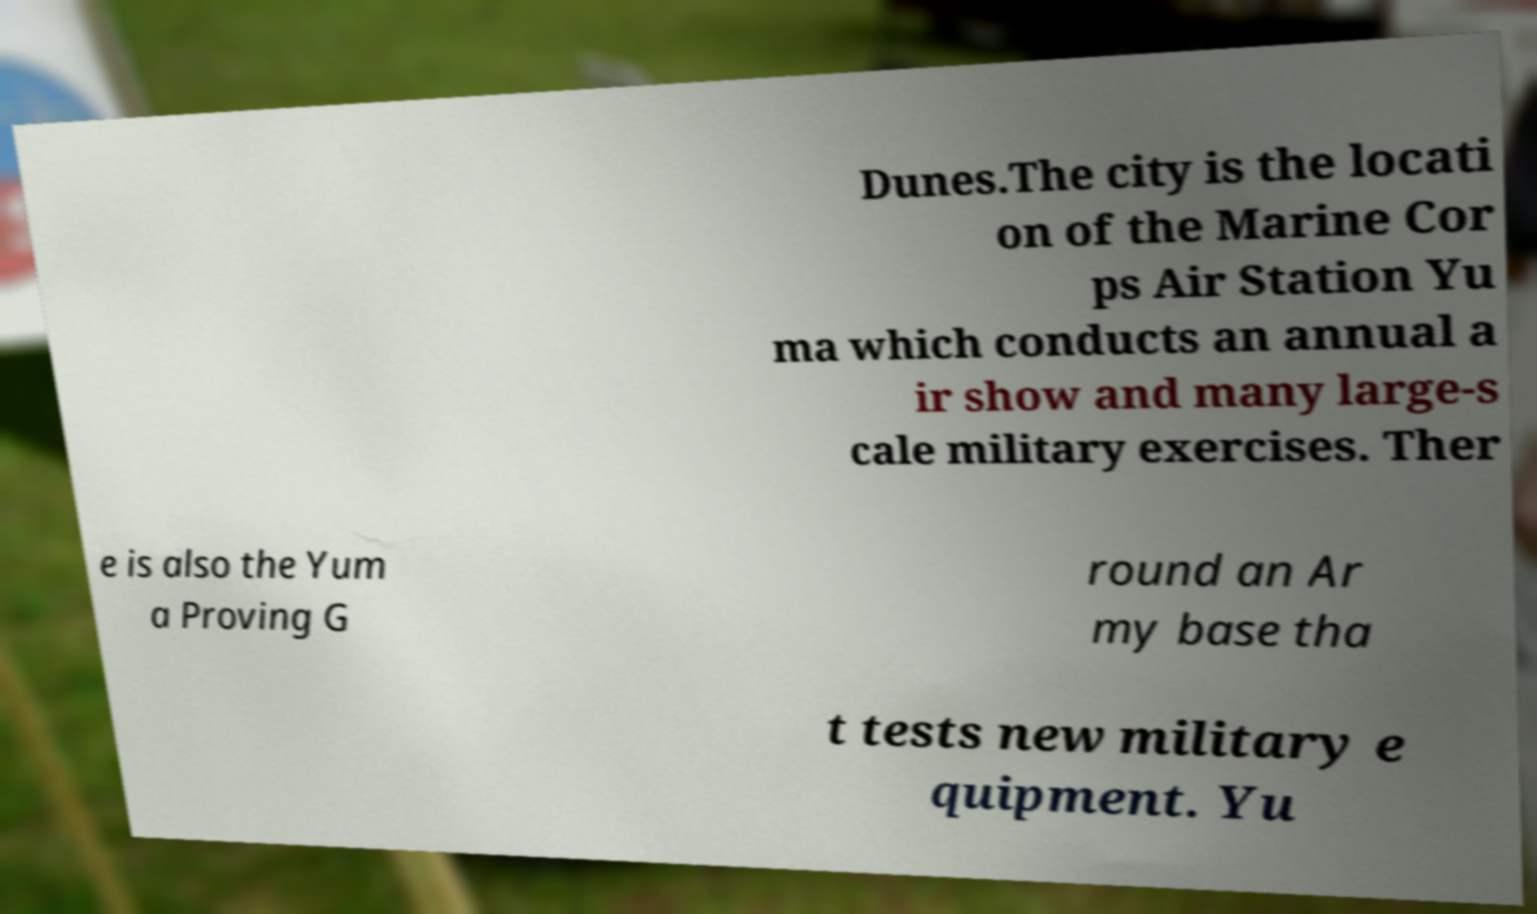I need the written content from this picture converted into text. Can you do that? Dunes.The city is the locati on of the Marine Cor ps Air Station Yu ma which conducts an annual a ir show and many large-s cale military exercises. Ther e is also the Yum a Proving G round an Ar my base tha t tests new military e quipment. Yu 